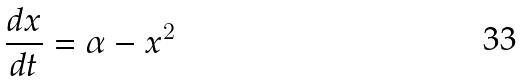<formula> <loc_0><loc_0><loc_500><loc_500>\frac { d x } { d t } = \alpha - x ^ { 2 }</formula> 